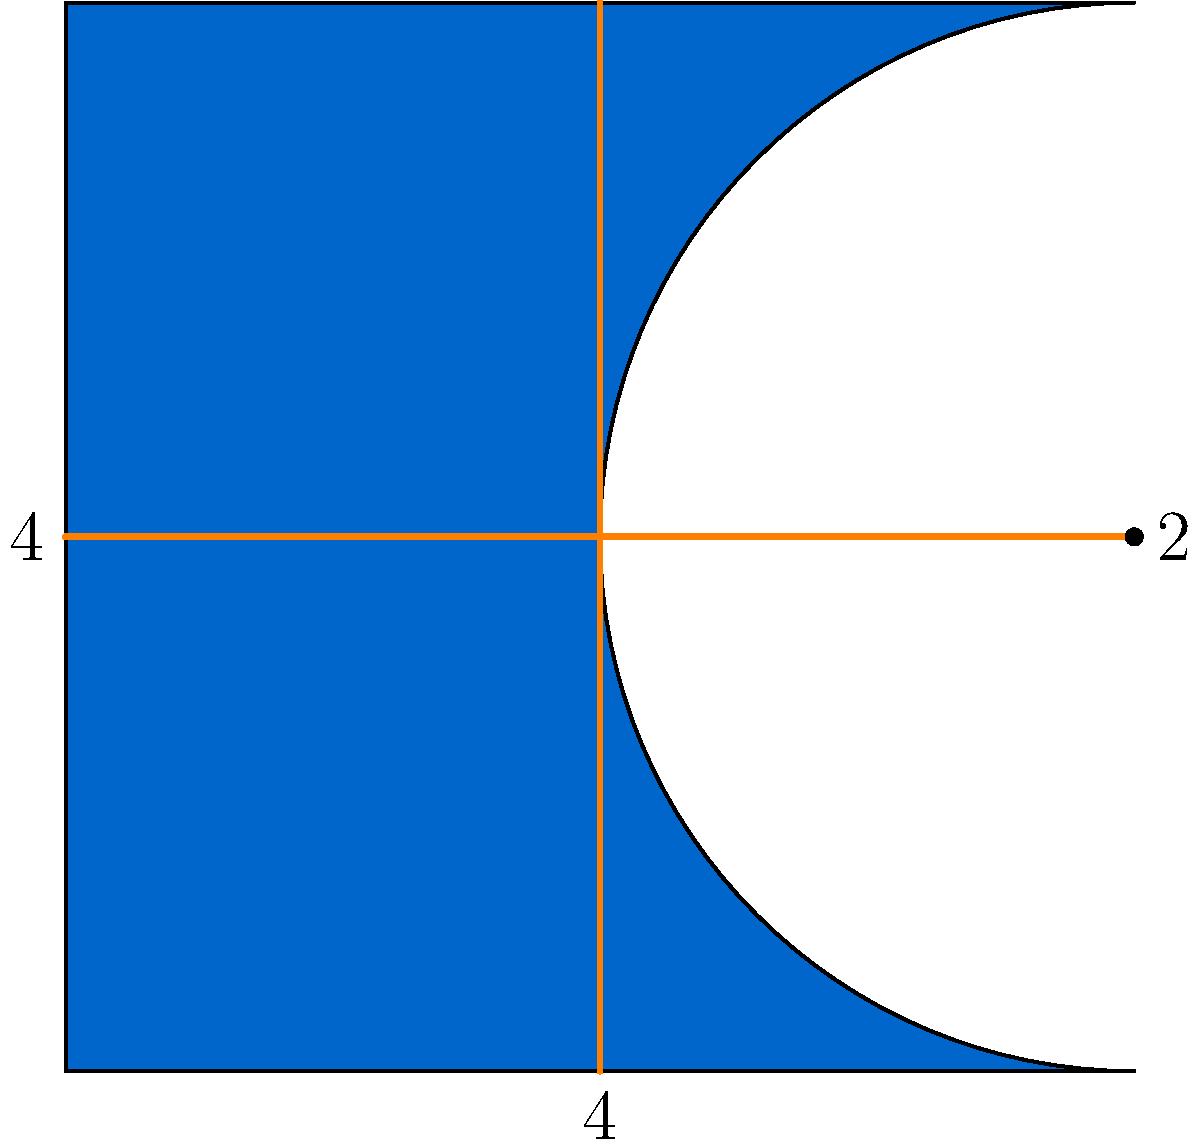The Horizen logo-inspired shape above is composed of a rectangle and a semicircle. If the width of the shape is 4 units and the height is also 4 units, what is the total area of this shape? Let's break this down step-by-step:

1. The shape is made up of a rectangle and a semicircle.

2. For the rectangle:
   - Width = 4 units
   - Height = 4 units
   - Area of rectangle = width × height
   - Area of rectangle = $4 \times 4 = 16$ square units

3. For the semicircle:
   - Diameter = 4 units (same as the width of the shape)
   - Radius = 2 units (half of the diameter)
   - Area of a full circle = $\pi r^2$
   - Area of semicircle = $\frac{1}{2} \pi r^2$
   - Area of semicircle = $\frac{1}{2} \times \pi \times 2^2 = 2\pi$ square units

4. Total area:
   - Total area = Area of rectangle + Area of semicircle
   - Total area = $16 + 2\pi$ square units

Therefore, the total area of the Horizen logo-inspired shape is $16 + 2\pi$ square units.
Answer: $16 + 2\pi$ square units 